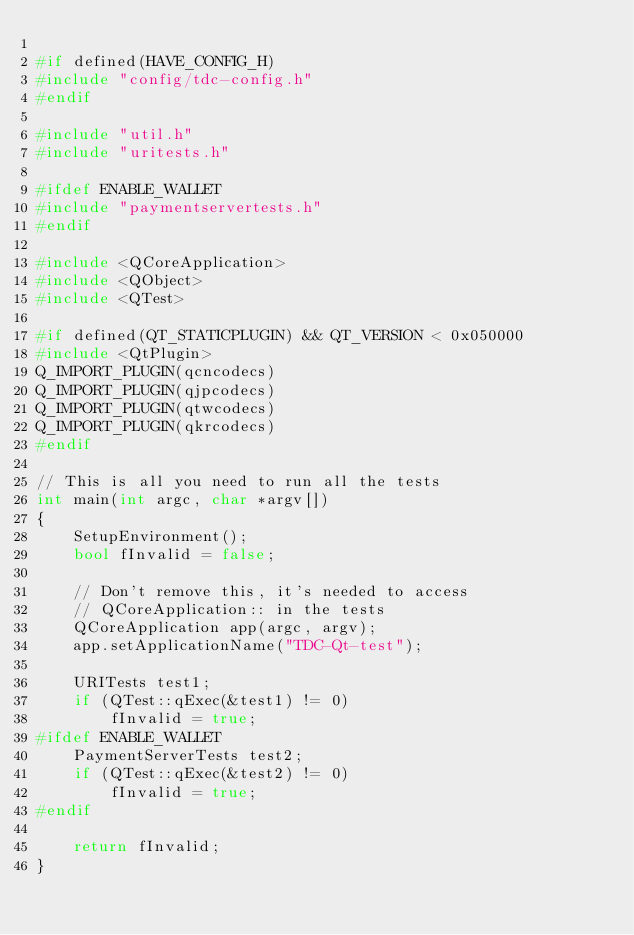Convert code to text. <code><loc_0><loc_0><loc_500><loc_500><_C++_>
#if defined(HAVE_CONFIG_H)
#include "config/tdc-config.h"
#endif

#include "util.h"
#include "uritests.h"

#ifdef ENABLE_WALLET
#include "paymentservertests.h"
#endif

#include <QCoreApplication>
#include <QObject>
#include <QTest>

#if defined(QT_STATICPLUGIN) && QT_VERSION < 0x050000
#include <QtPlugin>
Q_IMPORT_PLUGIN(qcncodecs)
Q_IMPORT_PLUGIN(qjpcodecs)
Q_IMPORT_PLUGIN(qtwcodecs)
Q_IMPORT_PLUGIN(qkrcodecs)
#endif

// This is all you need to run all the tests
int main(int argc, char *argv[])
{
    SetupEnvironment();
    bool fInvalid = false;

    // Don't remove this, it's needed to access
    // QCoreApplication:: in the tests
    QCoreApplication app(argc, argv);
    app.setApplicationName("TDC-Qt-test");

    URITests test1;
    if (QTest::qExec(&test1) != 0)
        fInvalid = true;
#ifdef ENABLE_WALLET
    PaymentServerTests test2;
    if (QTest::qExec(&test2) != 0)
        fInvalid = true;
#endif

    return fInvalid;
}
</code> 